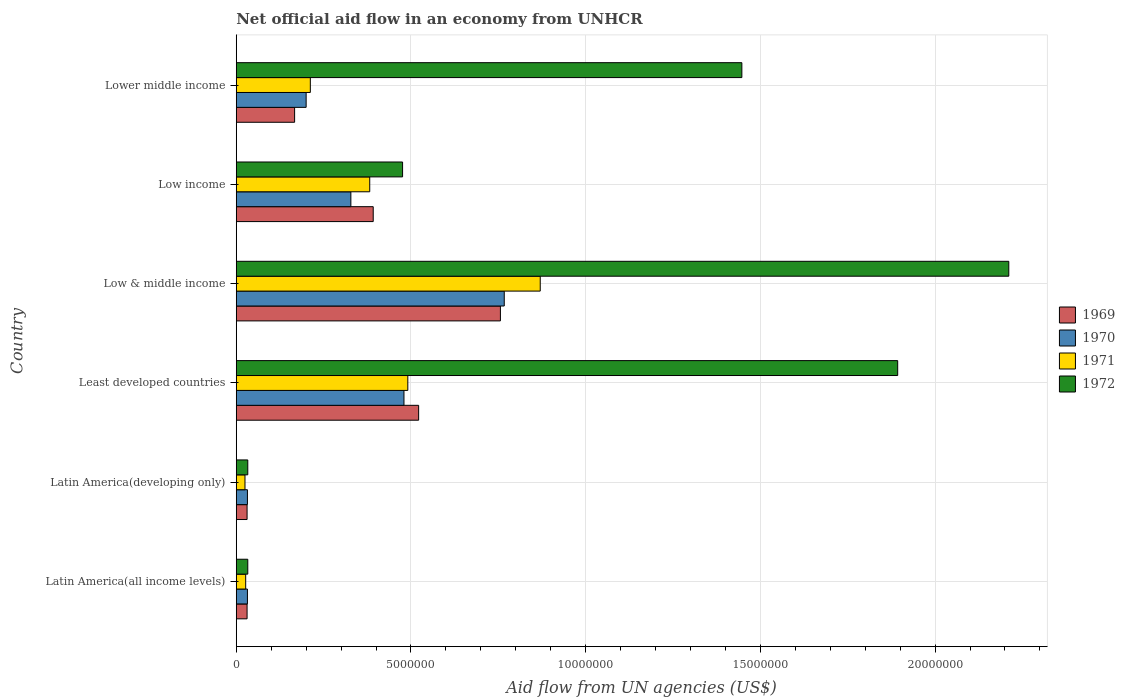How many groups of bars are there?
Your response must be concise. 6. Are the number of bars per tick equal to the number of legend labels?
Give a very brief answer. Yes. How many bars are there on the 5th tick from the top?
Your answer should be compact. 4. In how many cases, is the number of bars for a given country not equal to the number of legend labels?
Your response must be concise. 0. What is the net official aid flow in 1970 in Low & middle income?
Make the answer very short. 7.67e+06. Across all countries, what is the maximum net official aid flow in 1969?
Your response must be concise. 7.56e+06. Across all countries, what is the minimum net official aid flow in 1970?
Keep it short and to the point. 3.20e+05. In which country was the net official aid flow in 1970 minimum?
Offer a very short reply. Latin America(all income levels). What is the total net official aid flow in 1969 in the graph?
Provide a short and direct response. 1.90e+07. What is the difference between the net official aid flow in 1969 in Latin America(developing only) and that in Lower middle income?
Provide a succinct answer. -1.36e+06. What is the difference between the net official aid flow in 1971 in Latin America(all income levels) and the net official aid flow in 1969 in Least developed countries?
Ensure brevity in your answer.  -4.95e+06. What is the average net official aid flow in 1971 per country?
Make the answer very short. 3.34e+06. In how many countries, is the net official aid flow in 1969 greater than 16000000 US$?
Make the answer very short. 0. What is the ratio of the net official aid flow in 1970 in Low & middle income to that in Low income?
Ensure brevity in your answer.  2.34. Is the net official aid flow in 1970 in Latin America(all income levels) less than that in Lower middle income?
Provide a short and direct response. Yes. What is the difference between the highest and the second highest net official aid flow in 1972?
Your answer should be very brief. 3.18e+06. What is the difference between the highest and the lowest net official aid flow in 1970?
Offer a terse response. 7.35e+06. What does the 1st bar from the bottom in Least developed countries represents?
Offer a terse response. 1969. Is it the case that in every country, the sum of the net official aid flow in 1971 and net official aid flow in 1969 is greater than the net official aid flow in 1970?
Keep it short and to the point. Yes. How many countries are there in the graph?
Give a very brief answer. 6. What is the difference between two consecutive major ticks on the X-axis?
Your answer should be compact. 5.00e+06. Does the graph contain grids?
Make the answer very short. Yes. How many legend labels are there?
Provide a succinct answer. 4. What is the title of the graph?
Keep it short and to the point. Net official aid flow in an economy from UNHCR. Does "1967" appear as one of the legend labels in the graph?
Your answer should be very brief. No. What is the label or title of the X-axis?
Give a very brief answer. Aid flow from UN agencies (US$). What is the Aid flow from UN agencies (US$) in 1969 in Latin America(all income levels)?
Offer a very short reply. 3.10e+05. What is the Aid flow from UN agencies (US$) of 1970 in Latin America(all income levels)?
Your answer should be very brief. 3.20e+05. What is the Aid flow from UN agencies (US$) of 1972 in Latin America(all income levels)?
Your answer should be very brief. 3.30e+05. What is the Aid flow from UN agencies (US$) in 1970 in Latin America(developing only)?
Keep it short and to the point. 3.20e+05. What is the Aid flow from UN agencies (US$) of 1969 in Least developed countries?
Ensure brevity in your answer.  5.22e+06. What is the Aid flow from UN agencies (US$) in 1970 in Least developed countries?
Make the answer very short. 4.80e+06. What is the Aid flow from UN agencies (US$) in 1971 in Least developed countries?
Your answer should be compact. 4.91e+06. What is the Aid flow from UN agencies (US$) of 1972 in Least developed countries?
Your response must be concise. 1.89e+07. What is the Aid flow from UN agencies (US$) in 1969 in Low & middle income?
Your response must be concise. 7.56e+06. What is the Aid flow from UN agencies (US$) in 1970 in Low & middle income?
Offer a terse response. 7.67e+06. What is the Aid flow from UN agencies (US$) in 1971 in Low & middle income?
Make the answer very short. 8.70e+06. What is the Aid flow from UN agencies (US$) of 1972 in Low & middle income?
Your answer should be compact. 2.21e+07. What is the Aid flow from UN agencies (US$) of 1969 in Low income?
Provide a succinct answer. 3.92e+06. What is the Aid flow from UN agencies (US$) in 1970 in Low income?
Your answer should be very brief. 3.28e+06. What is the Aid flow from UN agencies (US$) in 1971 in Low income?
Offer a terse response. 3.82e+06. What is the Aid flow from UN agencies (US$) in 1972 in Low income?
Offer a terse response. 4.76e+06. What is the Aid flow from UN agencies (US$) in 1969 in Lower middle income?
Your response must be concise. 1.67e+06. What is the Aid flow from UN agencies (US$) of 1971 in Lower middle income?
Offer a terse response. 2.12e+06. What is the Aid flow from UN agencies (US$) of 1972 in Lower middle income?
Provide a succinct answer. 1.45e+07. Across all countries, what is the maximum Aid flow from UN agencies (US$) of 1969?
Ensure brevity in your answer.  7.56e+06. Across all countries, what is the maximum Aid flow from UN agencies (US$) in 1970?
Your answer should be very brief. 7.67e+06. Across all countries, what is the maximum Aid flow from UN agencies (US$) of 1971?
Your response must be concise. 8.70e+06. Across all countries, what is the maximum Aid flow from UN agencies (US$) in 1972?
Give a very brief answer. 2.21e+07. Across all countries, what is the minimum Aid flow from UN agencies (US$) in 1969?
Your answer should be very brief. 3.10e+05. Across all countries, what is the minimum Aid flow from UN agencies (US$) of 1971?
Offer a very short reply. 2.50e+05. Across all countries, what is the minimum Aid flow from UN agencies (US$) of 1972?
Keep it short and to the point. 3.30e+05. What is the total Aid flow from UN agencies (US$) of 1969 in the graph?
Your answer should be very brief. 1.90e+07. What is the total Aid flow from UN agencies (US$) in 1970 in the graph?
Provide a succinct answer. 1.84e+07. What is the total Aid flow from UN agencies (US$) in 1971 in the graph?
Your response must be concise. 2.01e+07. What is the total Aid flow from UN agencies (US$) of 1972 in the graph?
Provide a short and direct response. 6.09e+07. What is the difference between the Aid flow from UN agencies (US$) of 1969 in Latin America(all income levels) and that in Latin America(developing only)?
Provide a short and direct response. 0. What is the difference between the Aid flow from UN agencies (US$) in 1969 in Latin America(all income levels) and that in Least developed countries?
Your response must be concise. -4.91e+06. What is the difference between the Aid flow from UN agencies (US$) of 1970 in Latin America(all income levels) and that in Least developed countries?
Offer a terse response. -4.48e+06. What is the difference between the Aid flow from UN agencies (US$) of 1971 in Latin America(all income levels) and that in Least developed countries?
Offer a terse response. -4.64e+06. What is the difference between the Aid flow from UN agencies (US$) in 1972 in Latin America(all income levels) and that in Least developed countries?
Give a very brief answer. -1.86e+07. What is the difference between the Aid flow from UN agencies (US$) of 1969 in Latin America(all income levels) and that in Low & middle income?
Your answer should be compact. -7.25e+06. What is the difference between the Aid flow from UN agencies (US$) of 1970 in Latin America(all income levels) and that in Low & middle income?
Your answer should be very brief. -7.35e+06. What is the difference between the Aid flow from UN agencies (US$) in 1971 in Latin America(all income levels) and that in Low & middle income?
Provide a short and direct response. -8.43e+06. What is the difference between the Aid flow from UN agencies (US$) in 1972 in Latin America(all income levels) and that in Low & middle income?
Offer a very short reply. -2.18e+07. What is the difference between the Aid flow from UN agencies (US$) in 1969 in Latin America(all income levels) and that in Low income?
Make the answer very short. -3.61e+06. What is the difference between the Aid flow from UN agencies (US$) in 1970 in Latin America(all income levels) and that in Low income?
Offer a very short reply. -2.96e+06. What is the difference between the Aid flow from UN agencies (US$) of 1971 in Latin America(all income levels) and that in Low income?
Provide a short and direct response. -3.55e+06. What is the difference between the Aid flow from UN agencies (US$) in 1972 in Latin America(all income levels) and that in Low income?
Keep it short and to the point. -4.43e+06. What is the difference between the Aid flow from UN agencies (US$) in 1969 in Latin America(all income levels) and that in Lower middle income?
Give a very brief answer. -1.36e+06. What is the difference between the Aid flow from UN agencies (US$) of 1970 in Latin America(all income levels) and that in Lower middle income?
Keep it short and to the point. -1.68e+06. What is the difference between the Aid flow from UN agencies (US$) in 1971 in Latin America(all income levels) and that in Lower middle income?
Provide a short and direct response. -1.85e+06. What is the difference between the Aid flow from UN agencies (US$) in 1972 in Latin America(all income levels) and that in Lower middle income?
Your answer should be compact. -1.41e+07. What is the difference between the Aid flow from UN agencies (US$) of 1969 in Latin America(developing only) and that in Least developed countries?
Keep it short and to the point. -4.91e+06. What is the difference between the Aid flow from UN agencies (US$) in 1970 in Latin America(developing only) and that in Least developed countries?
Provide a succinct answer. -4.48e+06. What is the difference between the Aid flow from UN agencies (US$) of 1971 in Latin America(developing only) and that in Least developed countries?
Your answer should be very brief. -4.66e+06. What is the difference between the Aid flow from UN agencies (US$) in 1972 in Latin America(developing only) and that in Least developed countries?
Keep it short and to the point. -1.86e+07. What is the difference between the Aid flow from UN agencies (US$) in 1969 in Latin America(developing only) and that in Low & middle income?
Provide a short and direct response. -7.25e+06. What is the difference between the Aid flow from UN agencies (US$) in 1970 in Latin America(developing only) and that in Low & middle income?
Your answer should be very brief. -7.35e+06. What is the difference between the Aid flow from UN agencies (US$) in 1971 in Latin America(developing only) and that in Low & middle income?
Give a very brief answer. -8.45e+06. What is the difference between the Aid flow from UN agencies (US$) of 1972 in Latin America(developing only) and that in Low & middle income?
Your response must be concise. -2.18e+07. What is the difference between the Aid flow from UN agencies (US$) in 1969 in Latin America(developing only) and that in Low income?
Provide a succinct answer. -3.61e+06. What is the difference between the Aid flow from UN agencies (US$) in 1970 in Latin America(developing only) and that in Low income?
Offer a terse response. -2.96e+06. What is the difference between the Aid flow from UN agencies (US$) of 1971 in Latin America(developing only) and that in Low income?
Offer a very short reply. -3.57e+06. What is the difference between the Aid flow from UN agencies (US$) in 1972 in Latin America(developing only) and that in Low income?
Give a very brief answer. -4.43e+06. What is the difference between the Aid flow from UN agencies (US$) in 1969 in Latin America(developing only) and that in Lower middle income?
Offer a terse response. -1.36e+06. What is the difference between the Aid flow from UN agencies (US$) of 1970 in Latin America(developing only) and that in Lower middle income?
Provide a succinct answer. -1.68e+06. What is the difference between the Aid flow from UN agencies (US$) of 1971 in Latin America(developing only) and that in Lower middle income?
Offer a very short reply. -1.87e+06. What is the difference between the Aid flow from UN agencies (US$) in 1972 in Latin America(developing only) and that in Lower middle income?
Your answer should be compact. -1.41e+07. What is the difference between the Aid flow from UN agencies (US$) of 1969 in Least developed countries and that in Low & middle income?
Keep it short and to the point. -2.34e+06. What is the difference between the Aid flow from UN agencies (US$) in 1970 in Least developed countries and that in Low & middle income?
Your response must be concise. -2.87e+06. What is the difference between the Aid flow from UN agencies (US$) of 1971 in Least developed countries and that in Low & middle income?
Make the answer very short. -3.79e+06. What is the difference between the Aid flow from UN agencies (US$) in 1972 in Least developed countries and that in Low & middle income?
Offer a very short reply. -3.18e+06. What is the difference between the Aid flow from UN agencies (US$) of 1969 in Least developed countries and that in Low income?
Offer a very short reply. 1.30e+06. What is the difference between the Aid flow from UN agencies (US$) of 1970 in Least developed countries and that in Low income?
Your answer should be very brief. 1.52e+06. What is the difference between the Aid flow from UN agencies (US$) of 1971 in Least developed countries and that in Low income?
Offer a very short reply. 1.09e+06. What is the difference between the Aid flow from UN agencies (US$) in 1972 in Least developed countries and that in Low income?
Keep it short and to the point. 1.42e+07. What is the difference between the Aid flow from UN agencies (US$) in 1969 in Least developed countries and that in Lower middle income?
Give a very brief answer. 3.55e+06. What is the difference between the Aid flow from UN agencies (US$) of 1970 in Least developed countries and that in Lower middle income?
Give a very brief answer. 2.80e+06. What is the difference between the Aid flow from UN agencies (US$) of 1971 in Least developed countries and that in Lower middle income?
Your answer should be very brief. 2.79e+06. What is the difference between the Aid flow from UN agencies (US$) in 1972 in Least developed countries and that in Lower middle income?
Provide a succinct answer. 4.46e+06. What is the difference between the Aid flow from UN agencies (US$) of 1969 in Low & middle income and that in Low income?
Make the answer very short. 3.64e+06. What is the difference between the Aid flow from UN agencies (US$) of 1970 in Low & middle income and that in Low income?
Your answer should be compact. 4.39e+06. What is the difference between the Aid flow from UN agencies (US$) of 1971 in Low & middle income and that in Low income?
Provide a succinct answer. 4.88e+06. What is the difference between the Aid flow from UN agencies (US$) of 1972 in Low & middle income and that in Low income?
Your answer should be compact. 1.74e+07. What is the difference between the Aid flow from UN agencies (US$) of 1969 in Low & middle income and that in Lower middle income?
Make the answer very short. 5.89e+06. What is the difference between the Aid flow from UN agencies (US$) of 1970 in Low & middle income and that in Lower middle income?
Your answer should be very brief. 5.67e+06. What is the difference between the Aid flow from UN agencies (US$) of 1971 in Low & middle income and that in Lower middle income?
Provide a short and direct response. 6.58e+06. What is the difference between the Aid flow from UN agencies (US$) in 1972 in Low & middle income and that in Lower middle income?
Ensure brevity in your answer.  7.64e+06. What is the difference between the Aid flow from UN agencies (US$) of 1969 in Low income and that in Lower middle income?
Give a very brief answer. 2.25e+06. What is the difference between the Aid flow from UN agencies (US$) of 1970 in Low income and that in Lower middle income?
Your answer should be very brief. 1.28e+06. What is the difference between the Aid flow from UN agencies (US$) of 1971 in Low income and that in Lower middle income?
Give a very brief answer. 1.70e+06. What is the difference between the Aid flow from UN agencies (US$) of 1972 in Low income and that in Lower middle income?
Your answer should be compact. -9.71e+06. What is the difference between the Aid flow from UN agencies (US$) of 1969 in Latin America(all income levels) and the Aid flow from UN agencies (US$) of 1970 in Latin America(developing only)?
Make the answer very short. -10000. What is the difference between the Aid flow from UN agencies (US$) of 1969 in Latin America(all income levels) and the Aid flow from UN agencies (US$) of 1972 in Latin America(developing only)?
Offer a terse response. -2.00e+04. What is the difference between the Aid flow from UN agencies (US$) in 1969 in Latin America(all income levels) and the Aid flow from UN agencies (US$) in 1970 in Least developed countries?
Make the answer very short. -4.49e+06. What is the difference between the Aid flow from UN agencies (US$) in 1969 in Latin America(all income levels) and the Aid flow from UN agencies (US$) in 1971 in Least developed countries?
Ensure brevity in your answer.  -4.60e+06. What is the difference between the Aid flow from UN agencies (US$) of 1969 in Latin America(all income levels) and the Aid flow from UN agencies (US$) of 1972 in Least developed countries?
Make the answer very short. -1.86e+07. What is the difference between the Aid flow from UN agencies (US$) of 1970 in Latin America(all income levels) and the Aid flow from UN agencies (US$) of 1971 in Least developed countries?
Keep it short and to the point. -4.59e+06. What is the difference between the Aid flow from UN agencies (US$) in 1970 in Latin America(all income levels) and the Aid flow from UN agencies (US$) in 1972 in Least developed countries?
Your response must be concise. -1.86e+07. What is the difference between the Aid flow from UN agencies (US$) in 1971 in Latin America(all income levels) and the Aid flow from UN agencies (US$) in 1972 in Least developed countries?
Ensure brevity in your answer.  -1.87e+07. What is the difference between the Aid flow from UN agencies (US$) in 1969 in Latin America(all income levels) and the Aid flow from UN agencies (US$) in 1970 in Low & middle income?
Make the answer very short. -7.36e+06. What is the difference between the Aid flow from UN agencies (US$) in 1969 in Latin America(all income levels) and the Aid flow from UN agencies (US$) in 1971 in Low & middle income?
Your answer should be compact. -8.39e+06. What is the difference between the Aid flow from UN agencies (US$) in 1969 in Latin America(all income levels) and the Aid flow from UN agencies (US$) in 1972 in Low & middle income?
Provide a succinct answer. -2.18e+07. What is the difference between the Aid flow from UN agencies (US$) in 1970 in Latin America(all income levels) and the Aid flow from UN agencies (US$) in 1971 in Low & middle income?
Keep it short and to the point. -8.38e+06. What is the difference between the Aid flow from UN agencies (US$) of 1970 in Latin America(all income levels) and the Aid flow from UN agencies (US$) of 1972 in Low & middle income?
Ensure brevity in your answer.  -2.18e+07. What is the difference between the Aid flow from UN agencies (US$) in 1971 in Latin America(all income levels) and the Aid flow from UN agencies (US$) in 1972 in Low & middle income?
Offer a terse response. -2.18e+07. What is the difference between the Aid flow from UN agencies (US$) in 1969 in Latin America(all income levels) and the Aid flow from UN agencies (US$) in 1970 in Low income?
Make the answer very short. -2.97e+06. What is the difference between the Aid flow from UN agencies (US$) in 1969 in Latin America(all income levels) and the Aid flow from UN agencies (US$) in 1971 in Low income?
Offer a terse response. -3.51e+06. What is the difference between the Aid flow from UN agencies (US$) of 1969 in Latin America(all income levels) and the Aid flow from UN agencies (US$) of 1972 in Low income?
Make the answer very short. -4.45e+06. What is the difference between the Aid flow from UN agencies (US$) of 1970 in Latin America(all income levels) and the Aid flow from UN agencies (US$) of 1971 in Low income?
Provide a succinct answer. -3.50e+06. What is the difference between the Aid flow from UN agencies (US$) of 1970 in Latin America(all income levels) and the Aid flow from UN agencies (US$) of 1972 in Low income?
Your answer should be very brief. -4.44e+06. What is the difference between the Aid flow from UN agencies (US$) of 1971 in Latin America(all income levels) and the Aid flow from UN agencies (US$) of 1972 in Low income?
Provide a succinct answer. -4.49e+06. What is the difference between the Aid flow from UN agencies (US$) of 1969 in Latin America(all income levels) and the Aid flow from UN agencies (US$) of 1970 in Lower middle income?
Offer a very short reply. -1.69e+06. What is the difference between the Aid flow from UN agencies (US$) of 1969 in Latin America(all income levels) and the Aid flow from UN agencies (US$) of 1971 in Lower middle income?
Ensure brevity in your answer.  -1.81e+06. What is the difference between the Aid flow from UN agencies (US$) in 1969 in Latin America(all income levels) and the Aid flow from UN agencies (US$) in 1972 in Lower middle income?
Provide a succinct answer. -1.42e+07. What is the difference between the Aid flow from UN agencies (US$) in 1970 in Latin America(all income levels) and the Aid flow from UN agencies (US$) in 1971 in Lower middle income?
Your answer should be very brief. -1.80e+06. What is the difference between the Aid flow from UN agencies (US$) of 1970 in Latin America(all income levels) and the Aid flow from UN agencies (US$) of 1972 in Lower middle income?
Keep it short and to the point. -1.42e+07. What is the difference between the Aid flow from UN agencies (US$) in 1971 in Latin America(all income levels) and the Aid flow from UN agencies (US$) in 1972 in Lower middle income?
Offer a terse response. -1.42e+07. What is the difference between the Aid flow from UN agencies (US$) in 1969 in Latin America(developing only) and the Aid flow from UN agencies (US$) in 1970 in Least developed countries?
Provide a succinct answer. -4.49e+06. What is the difference between the Aid flow from UN agencies (US$) of 1969 in Latin America(developing only) and the Aid flow from UN agencies (US$) of 1971 in Least developed countries?
Your answer should be very brief. -4.60e+06. What is the difference between the Aid flow from UN agencies (US$) in 1969 in Latin America(developing only) and the Aid flow from UN agencies (US$) in 1972 in Least developed countries?
Your response must be concise. -1.86e+07. What is the difference between the Aid flow from UN agencies (US$) of 1970 in Latin America(developing only) and the Aid flow from UN agencies (US$) of 1971 in Least developed countries?
Your response must be concise. -4.59e+06. What is the difference between the Aid flow from UN agencies (US$) in 1970 in Latin America(developing only) and the Aid flow from UN agencies (US$) in 1972 in Least developed countries?
Offer a terse response. -1.86e+07. What is the difference between the Aid flow from UN agencies (US$) of 1971 in Latin America(developing only) and the Aid flow from UN agencies (US$) of 1972 in Least developed countries?
Your response must be concise. -1.87e+07. What is the difference between the Aid flow from UN agencies (US$) in 1969 in Latin America(developing only) and the Aid flow from UN agencies (US$) in 1970 in Low & middle income?
Offer a terse response. -7.36e+06. What is the difference between the Aid flow from UN agencies (US$) in 1969 in Latin America(developing only) and the Aid flow from UN agencies (US$) in 1971 in Low & middle income?
Offer a terse response. -8.39e+06. What is the difference between the Aid flow from UN agencies (US$) of 1969 in Latin America(developing only) and the Aid flow from UN agencies (US$) of 1972 in Low & middle income?
Keep it short and to the point. -2.18e+07. What is the difference between the Aid flow from UN agencies (US$) of 1970 in Latin America(developing only) and the Aid flow from UN agencies (US$) of 1971 in Low & middle income?
Provide a succinct answer. -8.38e+06. What is the difference between the Aid flow from UN agencies (US$) in 1970 in Latin America(developing only) and the Aid flow from UN agencies (US$) in 1972 in Low & middle income?
Ensure brevity in your answer.  -2.18e+07. What is the difference between the Aid flow from UN agencies (US$) in 1971 in Latin America(developing only) and the Aid flow from UN agencies (US$) in 1972 in Low & middle income?
Give a very brief answer. -2.19e+07. What is the difference between the Aid flow from UN agencies (US$) of 1969 in Latin America(developing only) and the Aid flow from UN agencies (US$) of 1970 in Low income?
Provide a succinct answer. -2.97e+06. What is the difference between the Aid flow from UN agencies (US$) of 1969 in Latin America(developing only) and the Aid flow from UN agencies (US$) of 1971 in Low income?
Ensure brevity in your answer.  -3.51e+06. What is the difference between the Aid flow from UN agencies (US$) in 1969 in Latin America(developing only) and the Aid flow from UN agencies (US$) in 1972 in Low income?
Offer a terse response. -4.45e+06. What is the difference between the Aid flow from UN agencies (US$) in 1970 in Latin America(developing only) and the Aid flow from UN agencies (US$) in 1971 in Low income?
Keep it short and to the point. -3.50e+06. What is the difference between the Aid flow from UN agencies (US$) in 1970 in Latin America(developing only) and the Aid flow from UN agencies (US$) in 1972 in Low income?
Ensure brevity in your answer.  -4.44e+06. What is the difference between the Aid flow from UN agencies (US$) of 1971 in Latin America(developing only) and the Aid flow from UN agencies (US$) of 1972 in Low income?
Make the answer very short. -4.51e+06. What is the difference between the Aid flow from UN agencies (US$) in 1969 in Latin America(developing only) and the Aid flow from UN agencies (US$) in 1970 in Lower middle income?
Give a very brief answer. -1.69e+06. What is the difference between the Aid flow from UN agencies (US$) of 1969 in Latin America(developing only) and the Aid flow from UN agencies (US$) of 1971 in Lower middle income?
Provide a succinct answer. -1.81e+06. What is the difference between the Aid flow from UN agencies (US$) in 1969 in Latin America(developing only) and the Aid flow from UN agencies (US$) in 1972 in Lower middle income?
Provide a succinct answer. -1.42e+07. What is the difference between the Aid flow from UN agencies (US$) in 1970 in Latin America(developing only) and the Aid flow from UN agencies (US$) in 1971 in Lower middle income?
Provide a succinct answer. -1.80e+06. What is the difference between the Aid flow from UN agencies (US$) in 1970 in Latin America(developing only) and the Aid flow from UN agencies (US$) in 1972 in Lower middle income?
Your answer should be compact. -1.42e+07. What is the difference between the Aid flow from UN agencies (US$) of 1971 in Latin America(developing only) and the Aid flow from UN agencies (US$) of 1972 in Lower middle income?
Offer a very short reply. -1.42e+07. What is the difference between the Aid flow from UN agencies (US$) in 1969 in Least developed countries and the Aid flow from UN agencies (US$) in 1970 in Low & middle income?
Offer a very short reply. -2.45e+06. What is the difference between the Aid flow from UN agencies (US$) of 1969 in Least developed countries and the Aid flow from UN agencies (US$) of 1971 in Low & middle income?
Provide a short and direct response. -3.48e+06. What is the difference between the Aid flow from UN agencies (US$) in 1969 in Least developed countries and the Aid flow from UN agencies (US$) in 1972 in Low & middle income?
Provide a succinct answer. -1.69e+07. What is the difference between the Aid flow from UN agencies (US$) of 1970 in Least developed countries and the Aid flow from UN agencies (US$) of 1971 in Low & middle income?
Make the answer very short. -3.90e+06. What is the difference between the Aid flow from UN agencies (US$) of 1970 in Least developed countries and the Aid flow from UN agencies (US$) of 1972 in Low & middle income?
Give a very brief answer. -1.73e+07. What is the difference between the Aid flow from UN agencies (US$) of 1971 in Least developed countries and the Aid flow from UN agencies (US$) of 1972 in Low & middle income?
Give a very brief answer. -1.72e+07. What is the difference between the Aid flow from UN agencies (US$) in 1969 in Least developed countries and the Aid flow from UN agencies (US$) in 1970 in Low income?
Offer a very short reply. 1.94e+06. What is the difference between the Aid flow from UN agencies (US$) of 1969 in Least developed countries and the Aid flow from UN agencies (US$) of 1971 in Low income?
Your answer should be very brief. 1.40e+06. What is the difference between the Aid flow from UN agencies (US$) of 1970 in Least developed countries and the Aid flow from UN agencies (US$) of 1971 in Low income?
Make the answer very short. 9.80e+05. What is the difference between the Aid flow from UN agencies (US$) of 1970 in Least developed countries and the Aid flow from UN agencies (US$) of 1972 in Low income?
Your answer should be compact. 4.00e+04. What is the difference between the Aid flow from UN agencies (US$) of 1969 in Least developed countries and the Aid flow from UN agencies (US$) of 1970 in Lower middle income?
Provide a succinct answer. 3.22e+06. What is the difference between the Aid flow from UN agencies (US$) of 1969 in Least developed countries and the Aid flow from UN agencies (US$) of 1971 in Lower middle income?
Make the answer very short. 3.10e+06. What is the difference between the Aid flow from UN agencies (US$) in 1969 in Least developed countries and the Aid flow from UN agencies (US$) in 1972 in Lower middle income?
Your answer should be compact. -9.25e+06. What is the difference between the Aid flow from UN agencies (US$) of 1970 in Least developed countries and the Aid flow from UN agencies (US$) of 1971 in Lower middle income?
Make the answer very short. 2.68e+06. What is the difference between the Aid flow from UN agencies (US$) in 1970 in Least developed countries and the Aid flow from UN agencies (US$) in 1972 in Lower middle income?
Offer a very short reply. -9.67e+06. What is the difference between the Aid flow from UN agencies (US$) of 1971 in Least developed countries and the Aid flow from UN agencies (US$) of 1972 in Lower middle income?
Keep it short and to the point. -9.56e+06. What is the difference between the Aid flow from UN agencies (US$) of 1969 in Low & middle income and the Aid flow from UN agencies (US$) of 1970 in Low income?
Give a very brief answer. 4.28e+06. What is the difference between the Aid flow from UN agencies (US$) in 1969 in Low & middle income and the Aid flow from UN agencies (US$) in 1971 in Low income?
Give a very brief answer. 3.74e+06. What is the difference between the Aid flow from UN agencies (US$) of 1969 in Low & middle income and the Aid flow from UN agencies (US$) of 1972 in Low income?
Your answer should be compact. 2.80e+06. What is the difference between the Aid flow from UN agencies (US$) in 1970 in Low & middle income and the Aid flow from UN agencies (US$) in 1971 in Low income?
Offer a very short reply. 3.85e+06. What is the difference between the Aid flow from UN agencies (US$) in 1970 in Low & middle income and the Aid flow from UN agencies (US$) in 1972 in Low income?
Provide a short and direct response. 2.91e+06. What is the difference between the Aid flow from UN agencies (US$) of 1971 in Low & middle income and the Aid flow from UN agencies (US$) of 1972 in Low income?
Offer a terse response. 3.94e+06. What is the difference between the Aid flow from UN agencies (US$) of 1969 in Low & middle income and the Aid flow from UN agencies (US$) of 1970 in Lower middle income?
Provide a short and direct response. 5.56e+06. What is the difference between the Aid flow from UN agencies (US$) of 1969 in Low & middle income and the Aid flow from UN agencies (US$) of 1971 in Lower middle income?
Your answer should be very brief. 5.44e+06. What is the difference between the Aid flow from UN agencies (US$) of 1969 in Low & middle income and the Aid flow from UN agencies (US$) of 1972 in Lower middle income?
Your answer should be compact. -6.91e+06. What is the difference between the Aid flow from UN agencies (US$) of 1970 in Low & middle income and the Aid flow from UN agencies (US$) of 1971 in Lower middle income?
Your answer should be compact. 5.55e+06. What is the difference between the Aid flow from UN agencies (US$) of 1970 in Low & middle income and the Aid flow from UN agencies (US$) of 1972 in Lower middle income?
Offer a very short reply. -6.80e+06. What is the difference between the Aid flow from UN agencies (US$) of 1971 in Low & middle income and the Aid flow from UN agencies (US$) of 1972 in Lower middle income?
Offer a terse response. -5.77e+06. What is the difference between the Aid flow from UN agencies (US$) of 1969 in Low income and the Aid flow from UN agencies (US$) of 1970 in Lower middle income?
Your response must be concise. 1.92e+06. What is the difference between the Aid flow from UN agencies (US$) of 1969 in Low income and the Aid flow from UN agencies (US$) of 1971 in Lower middle income?
Offer a terse response. 1.80e+06. What is the difference between the Aid flow from UN agencies (US$) in 1969 in Low income and the Aid flow from UN agencies (US$) in 1972 in Lower middle income?
Your response must be concise. -1.06e+07. What is the difference between the Aid flow from UN agencies (US$) in 1970 in Low income and the Aid flow from UN agencies (US$) in 1971 in Lower middle income?
Offer a very short reply. 1.16e+06. What is the difference between the Aid flow from UN agencies (US$) of 1970 in Low income and the Aid flow from UN agencies (US$) of 1972 in Lower middle income?
Your answer should be compact. -1.12e+07. What is the difference between the Aid flow from UN agencies (US$) in 1971 in Low income and the Aid flow from UN agencies (US$) in 1972 in Lower middle income?
Keep it short and to the point. -1.06e+07. What is the average Aid flow from UN agencies (US$) of 1969 per country?
Offer a terse response. 3.16e+06. What is the average Aid flow from UN agencies (US$) in 1970 per country?
Provide a short and direct response. 3.06e+06. What is the average Aid flow from UN agencies (US$) of 1971 per country?
Give a very brief answer. 3.34e+06. What is the average Aid flow from UN agencies (US$) in 1972 per country?
Offer a very short reply. 1.02e+07. What is the difference between the Aid flow from UN agencies (US$) in 1969 and Aid flow from UN agencies (US$) in 1970 in Latin America(all income levels)?
Give a very brief answer. -10000. What is the difference between the Aid flow from UN agencies (US$) of 1969 and Aid flow from UN agencies (US$) of 1971 in Latin America(all income levels)?
Your response must be concise. 4.00e+04. What is the difference between the Aid flow from UN agencies (US$) in 1969 and Aid flow from UN agencies (US$) in 1972 in Latin America(all income levels)?
Provide a short and direct response. -2.00e+04. What is the difference between the Aid flow from UN agencies (US$) of 1970 and Aid flow from UN agencies (US$) of 1971 in Latin America(all income levels)?
Provide a succinct answer. 5.00e+04. What is the difference between the Aid flow from UN agencies (US$) of 1971 and Aid flow from UN agencies (US$) of 1972 in Latin America(all income levels)?
Your response must be concise. -6.00e+04. What is the difference between the Aid flow from UN agencies (US$) in 1969 and Aid flow from UN agencies (US$) in 1970 in Latin America(developing only)?
Provide a succinct answer. -10000. What is the difference between the Aid flow from UN agencies (US$) of 1969 and Aid flow from UN agencies (US$) of 1971 in Latin America(developing only)?
Your answer should be compact. 6.00e+04. What is the difference between the Aid flow from UN agencies (US$) in 1969 and Aid flow from UN agencies (US$) in 1972 in Latin America(developing only)?
Your answer should be compact. -2.00e+04. What is the difference between the Aid flow from UN agencies (US$) in 1970 and Aid flow from UN agencies (US$) in 1972 in Latin America(developing only)?
Make the answer very short. -10000. What is the difference between the Aid flow from UN agencies (US$) in 1971 and Aid flow from UN agencies (US$) in 1972 in Latin America(developing only)?
Make the answer very short. -8.00e+04. What is the difference between the Aid flow from UN agencies (US$) in 1969 and Aid flow from UN agencies (US$) in 1970 in Least developed countries?
Provide a succinct answer. 4.20e+05. What is the difference between the Aid flow from UN agencies (US$) of 1969 and Aid flow from UN agencies (US$) of 1972 in Least developed countries?
Provide a short and direct response. -1.37e+07. What is the difference between the Aid flow from UN agencies (US$) of 1970 and Aid flow from UN agencies (US$) of 1971 in Least developed countries?
Your answer should be very brief. -1.10e+05. What is the difference between the Aid flow from UN agencies (US$) of 1970 and Aid flow from UN agencies (US$) of 1972 in Least developed countries?
Offer a very short reply. -1.41e+07. What is the difference between the Aid flow from UN agencies (US$) of 1971 and Aid flow from UN agencies (US$) of 1972 in Least developed countries?
Your response must be concise. -1.40e+07. What is the difference between the Aid flow from UN agencies (US$) of 1969 and Aid flow from UN agencies (US$) of 1970 in Low & middle income?
Make the answer very short. -1.10e+05. What is the difference between the Aid flow from UN agencies (US$) of 1969 and Aid flow from UN agencies (US$) of 1971 in Low & middle income?
Make the answer very short. -1.14e+06. What is the difference between the Aid flow from UN agencies (US$) of 1969 and Aid flow from UN agencies (US$) of 1972 in Low & middle income?
Provide a succinct answer. -1.46e+07. What is the difference between the Aid flow from UN agencies (US$) in 1970 and Aid flow from UN agencies (US$) in 1971 in Low & middle income?
Give a very brief answer. -1.03e+06. What is the difference between the Aid flow from UN agencies (US$) of 1970 and Aid flow from UN agencies (US$) of 1972 in Low & middle income?
Make the answer very short. -1.44e+07. What is the difference between the Aid flow from UN agencies (US$) in 1971 and Aid flow from UN agencies (US$) in 1972 in Low & middle income?
Provide a short and direct response. -1.34e+07. What is the difference between the Aid flow from UN agencies (US$) in 1969 and Aid flow from UN agencies (US$) in 1970 in Low income?
Your answer should be very brief. 6.40e+05. What is the difference between the Aid flow from UN agencies (US$) of 1969 and Aid flow from UN agencies (US$) of 1971 in Low income?
Provide a short and direct response. 1.00e+05. What is the difference between the Aid flow from UN agencies (US$) in 1969 and Aid flow from UN agencies (US$) in 1972 in Low income?
Give a very brief answer. -8.40e+05. What is the difference between the Aid flow from UN agencies (US$) of 1970 and Aid flow from UN agencies (US$) of 1971 in Low income?
Your answer should be very brief. -5.40e+05. What is the difference between the Aid flow from UN agencies (US$) of 1970 and Aid flow from UN agencies (US$) of 1972 in Low income?
Your answer should be compact. -1.48e+06. What is the difference between the Aid flow from UN agencies (US$) of 1971 and Aid flow from UN agencies (US$) of 1972 in Low income?
Keep it short and to the point. -9.40e+05. What is the difference between the Aid flow from UN agencies (US$) in 1969 and Aid flow from UN agencies (US$) in 1970 in Lower middle income?
Offer a terse response. -3.30e+05. What is the difference between the Aid flow from UN agencies (US$) in 1969 and Aid flow from UN agencies (US$) in 1971 in Lower middle income?
Give a very brief answer. -4.50e+05. What is the difference between the Aid flow from UN agencies (US$) of 1969 and Aid flow from UN agencies (US$) of 1972 in Lower middle income?
Your answer should be compact. -1.28e+07. What is the difference between the Aid flow from UN agencies (US$) in 1970 and Aid flow from UN agencies (US$) in 1971 in Lower middle income?
Make the answer very short. -1.20e+05. What is the difference between the Aid flow from UN agencies (US$) in 1970 and Aid flow from UN agencies (US$) in 1972 in Lower middle income?
Your response must be concise. -1.25e+07. What is the difference between the Aid flow from UN agencies (US$) in 1971 and Aid flow from UN agencies (US$) in 1972 in Lower middle income?
Provide a succinct answer. -1.24e+07. What is the ratio of the Aid flow from UN agencies (US$) in 1969 in Latin America(all income levels) to that in Least developed countries?
Provide a succinct answer. 0.06. What is the ratio of the Aid flow from UN agencies (US$) of 1970 in Latin America(all income levels) to that in Least developed countries?
Offer a terse response. 0.07. What is the ratio of the Aid flow from UN agencies (US$) of 1971 in Latin America(all income levels) to that in Least developed countries?
Provide a succinct answer. 0.06. What is the ratio of the Aid flow from UN agencies (US$) in 1972 in Latin America(all income levels) to that in Least developed countries?
Your response must be concise. 0.02. What is the ratio of the Aid flow from UN agencies (US$) in 1969 in Latin America(all income levels) to that in Low & middle income?
Keep it short and to the point. 0.04. What is the ratio of the Aid flow from UN agencies (US$) in 1970 in Latin America(all income levels) to that in Low & middle income?
Provide a succinct answer. 0.04. What is the ratio of the Aid flow from UN agencies (US$) of 1971 in Latin America(all income levels) to that in Low & middle income?
Give a very brief answer. 0.03. What is the ratio of the Aid flow from UN agencies (US$) in 1972 in Latin America(all income levels) to that in Low & middle income?
Provide a succinct answer. 0.01. What is the ratio of the Aid flow from UN agencies (US$) in 1969 in Latin America(all income levels) to that in Low income?
Give a very brief answer. 0.08. What is the ratio of the Aid flow from UN agencies (US$) in 1970 in Latin America(all income levels) to that in Low income?
Offer a very short reply. 0.1. What is the ratio of the Aid flow from UN agencies (US$) in 1971 in Latin America(all income levels) to that in Low income?
Provide a short and direct response. 0.07. What is the ratio of the Aid flow from UN agencies (US$) in 1972 in Latin America(all income levels) to that in Low income?
Offer a very short reply. 0.07. What is the ratio of the Aid flow from UN agencies (US$) of 1969 in Latin America(all income levels) to that in Lower middle income?
Make the answer very short. 0.19. What is the ratio of the Aid flow from UN agencies (US$) in 1970 in Latin America(all income levels) to that in Lower middle income?
Your response must be concise. 0.16. What is the ratio of the Aid flow from UN agencies (US$) of 1971 in Latin America(all income levels) to that in Lower middle income?
Your answer should be very brief. 0.13. What is the ratio of the Aid flow from UN agencies (US$) in 1972 in Latin America(all income levels) to that in Lower middle income?
Give a very brief answer. 0.02. What is the ratio of the Aid flow from UN agencies (US$) of 1969 in Latin America(developing only) to that in Least developed countries?
Provide a succinct answer. 0.06. What is the ratio of the Aid flow from UN agencies (US$) in 1970 in Latin America(developing only) to that in Least developed countries?
Provide a short and direct response. 0.07. What is the ratio of the Aid flow from UN agencies (US$) in 1971 in Latin America(developing only) to that in Least developed countries?
Make the answer very short. 0.05. What is the ratio of the Aid flow from UN agencies (US$) of 1972 in Latin America(developing only) to that in Least developed countries?
Your response must be concise. 0.02. What is the ratio of the Aid flow from UN agencies (US$) in 1969 in Latin America(developing only) to that in Low & middle income?
Offer a terse response. 0.04. What is the ratio of the Aid flow from UN agencies (US$) in 1970 in Latin America(developing only) to that in Low & middle income?
Give a very brief answer. 0.04. What is the ratio of the Aid flow from UN agencies (US$) in 1971 in Latin America(developing only) to that in Low & middle income?
Provide a short and direct response. 0.03. What is the ratio of the Aid flow from UN agencies (US$) of 1972 in Latin America(developing only) to that in Low & middle income?
Your response must be concise. 0.01. What is the ratio of the Aid flow from UN agencies (US$) in 1969 in Latin America(developing only) to that in Low income?
Your answer should be compact. 0.08. What is the ratio of the Aid flow from UN agencies (US$) in 1970 in Latin America(developing only) to that in Low income?
Keep it short and to the point. 0.1. What is the ratio of the Aid flow from UN agencies (US$) in 1971 in Latin America(developing only) to that in Low income?
Provide a short and direct response. 0.07. What is the ratio of the Aid flow from UN agencies (US$) in 1972 in Latin America(developing only) to that in Low income?
Keep it short and to the point. 0.07. What is the ratio of the Aid flow from UN agencies (US$) of 1969 in Latin America(developing only) to that in Lower middle income?
Provide a short and direct response. 0.19. What is the ratio of the Aid flow from UN agencies (US$) of 1970 in Latin America(developing only) to that in Lower middle income?
Your answer should be very brief. 0.16. What is the ratio of the Aid flow from UN agencies (US$) of 1971 in Latin America(developing only) to that in Lower middle income?
Give a very brief answer. 0.12. What is the ratio of the Aid flow from UN agencies (US$) of 1972 in Latin America(developing only) to that in Lower middle income?
Provide a succinct answer. 0.02. What is the ratio of the Aid flow from UN agencies (US$) in 1969 in Least developed countries to that in Low & middle income?
Ensure brevity in your answer.  0.69. What is the ratio of the Aid flow from UN agencies (US$) in 1970 in Least developed countries to that in Low & middle income?
Provide a succinct answer. 0.63. What is the ratio of the Aid flow from UN agencies (US$) in 1971 in Least developed countries to that in Low & middle income?
Offer a terse response. 0.56. What is the ratio of the Aid flow from UN agencies (US$) in 1972 in Least developed countries to that in Low & middle income?
Your answer should be very brief. 0.86. What is the ratio of the Aid flow from UN agencies (US$) in 1969 in Least developed countries to that in Low income?
Provide a short and direct response. 1.33. What is the ratio of the Aid flow from UN agencies (US$) in 1970 in Least developed countries to that in Low income?
Give a very brief answer. 1.46. What is the ratio of the Aid flow from UN agencies (US$) in 1971 in Least developed countries to that in Low income?
Keep it short and to the point. 1.29. What is the ratio of the Aid flow from UN agencies (US$) in 1972 in Least developed countries to that in Low income?
Offer a very short reply. 3.98. What is the ratio of the Aid flow from UN agencies (US$) in 1969 in Least developed countries to that in Lower middle income?
Give a very brief answer. 3.13. What is the ratio of the Aid flow from UN agencies (US$) in 1971 in Least developed countries to that in Lower middle income?
Make the answer very short. 2.32. What is the ratio of the Aid flow from UN agencies (US$) in 1972 in Least developed countries to that in Lower middle income?
Offer a terse response. 1.31. What is the ratio of the Aid flow from UN agencies (US$) of 1969 in Low & middle income to that in Low income?
Your answer should be compact. 1.93. What is the ratio of the Aid flow from UN agencies (US$) in 1970 in Low & middle income to that in Low income?
Give a very brief answer. 2.34. What is the ratio of the Aid flow from UN agencies (US$) in 1971 in Low & middle income to that in Low income?
Provide a short and direct response. 2.28. What is the ratio of the Aid flow from UN agencies (US$) in 1972 in Low & middle income to that in Low income?
Keep it short and to the point. 4.64. What is the ratio of the Aid flow from UN agencies (US$) of 1969 in Low & middle income to that in Lower middle income?
Keep it short and to the point. 4.53. What is the ratio of the Aid flow from UN agencies (US$) of 1970 in Low & middle income to that in Lower middle income?
Give a very brief answer. 3.83. What is the ratio of the Aid flow from UN agencies (US$) of 1971 in Low & middle income to that in Lower middle income?
Offer a terse response. 4.1. What is the ratio of the Aid flow from UN agencies (US$) in 1972 in Low & middle income to that in Lower middle income?
Your answer should be very brief. 1.53. What is the ratio of the Aid flow from UN agencies (US$) of 1969 in Low income to that in Lower middle income?
Your answer should be compact. 2.35. What is the ratio of the Aid flow from UN agencies (US$) in 1970 in Low income to that in Lower middle income?
Offer a very short reply. 1.64. What is the ratio of the Aid flow from UN agencies (US$) in 1971 in Low income to that in Lower middle income?
Your answer should be very brief. 1.8. What is the ratio of the Aid flow from UN agencies (US$) of 1972 in Low income to that in Lower middle income?
Give a very brief answer. 0.33. What is the difference between the highest and the second highest Aid flow from UN agencies (US$) in 1969?
Give a very brief answer. 2.34e+06. What is the difference between the highest and the second highest Aid flow from UN agencies (US$) of 1970?
Provide a succinct answer. 2.87e+06. What is the difference between the highest and the second highest Aid flow from UN agencies (US$) of 1971?
Ensure brevity in your answer.  3.79e+06. What is the difference between the highest and the second highest Aid flow from UN agencies (US$) in 1972?
Your answer should be very brief. 3.18e+06. What is the difference between the highest and the lowest Aid flow from UN agencies (US$) of 1969?
Ensure brevity in your answer.  7.25e+06. What is the difference between the highest and the lowest Aid flow from UN agencies (US$) in 1970?
Your response must be concise. 7.35e+06. What is the difference between the highest and the lowest Aid flow from UN agencies (US$) in 1971?
Your answer should be very brief. 8.45e+06. What is the difference between the highest and the lowest Aid flow from UN agencies (US$) in 1972?
Make the answer very short. 2.18e+07. 